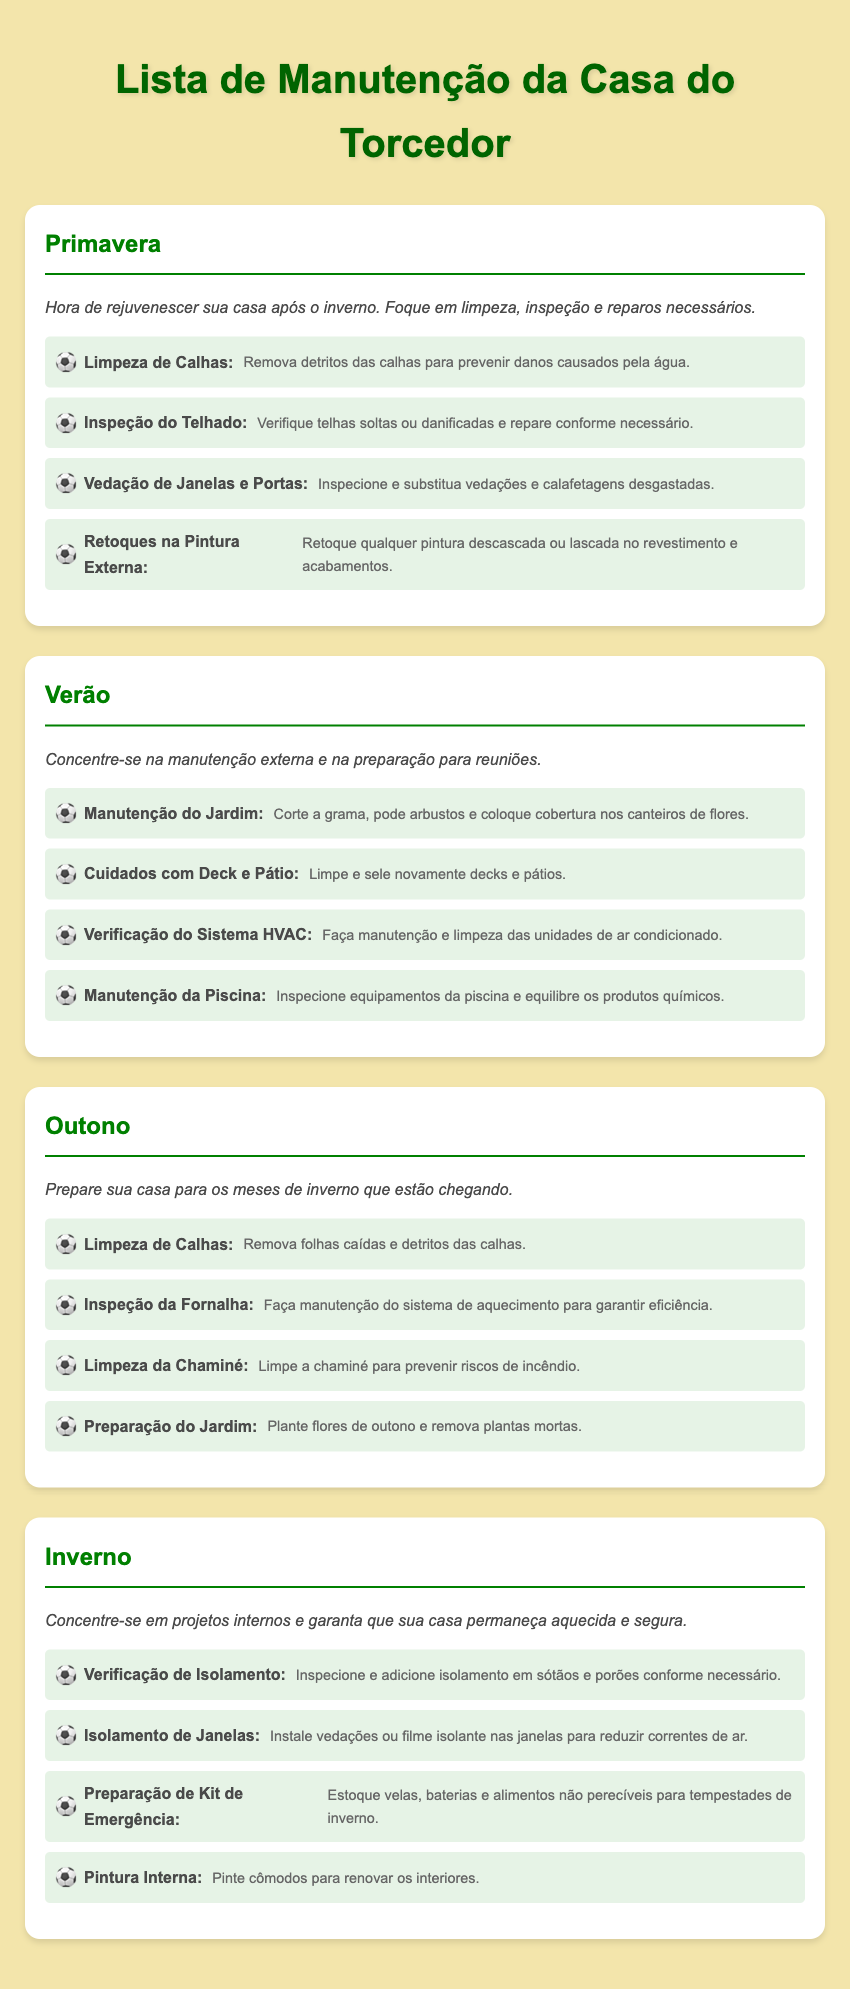Qual é a primeira estação mencionada na lista? A primeira estação listada no documento é a Primavera.
Answer: Primavera Quantas tarefas estão listadas para o verão? No verão, há quatro tarefas listadas no documento.
Answer: 4 O que deve ser inspecionado e limpo no outono? No outono, a fornalha deve ser inspecionada e limpa.
Answer: Fornalha Qual tarefa é sugerida para o inverno relacionada à proteção das janelas? No inverno, recomenda-se instalar vedações ou filme isolante nas janelas.
Answer: Vedações Qual é a tarefa relacionada ao jardim na primavera? Na primavera, a tarefa relacionada ao jardim é a limpeza de calhas.
Answer: Limpeza de Calhas Quais são os produtos químicos que devem ser equilibrados durante o verão? Durante o verão, os produtos químicos da piscina devem ser equilibrados.
Answer: Produtos químicos da piscina O que deve ser feito com as calhas no outono? No outono, as calhas devem ser limpas para remover folhas caídas e detritos.
Answer: Limpeza de Calhas Qual é a tarefa de manutenção mencionada para o telhado na primavera? Na primavera, a tarefa de manutenção do telhado é a inspeção de telhas.
Answer: Inspeção do Telhado Qual preparação é sugerida para o kit de emergência no inverno? Para o inverno, sugere-se estocar velas, baterias e alimentos não perecíveis.
Answer: Velas, baterias e alimentos não perecíveis 